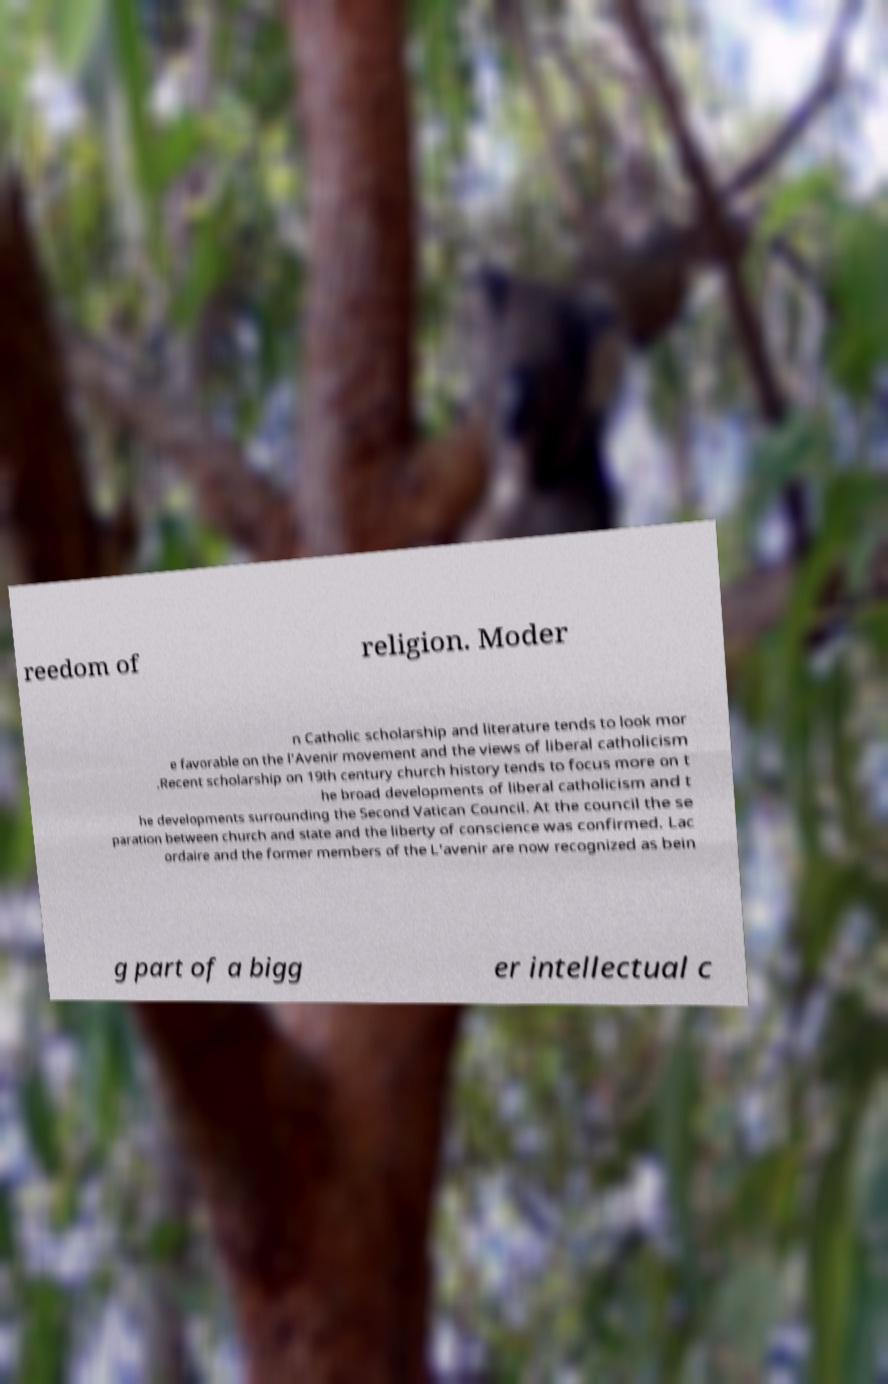For documentation purposes, I need the text within this image transcribed. Could you provide that? reedom of religion. Moder n Catholic scholarship and literature tends to look mor e favorable on the l’Avenir movement and the views of liberal catholicism .Recent scholarship on 19th century church history tends to focus more on t he broad developments of liberal catholicism and t he developments surrounding the Second Vatican Council. At the council the se paration between church and state and the liberty of conscience was confirmed. Lac ordaire and the former members of the L'avenir are now recognized as bein g part of a bigg er intellectual c 